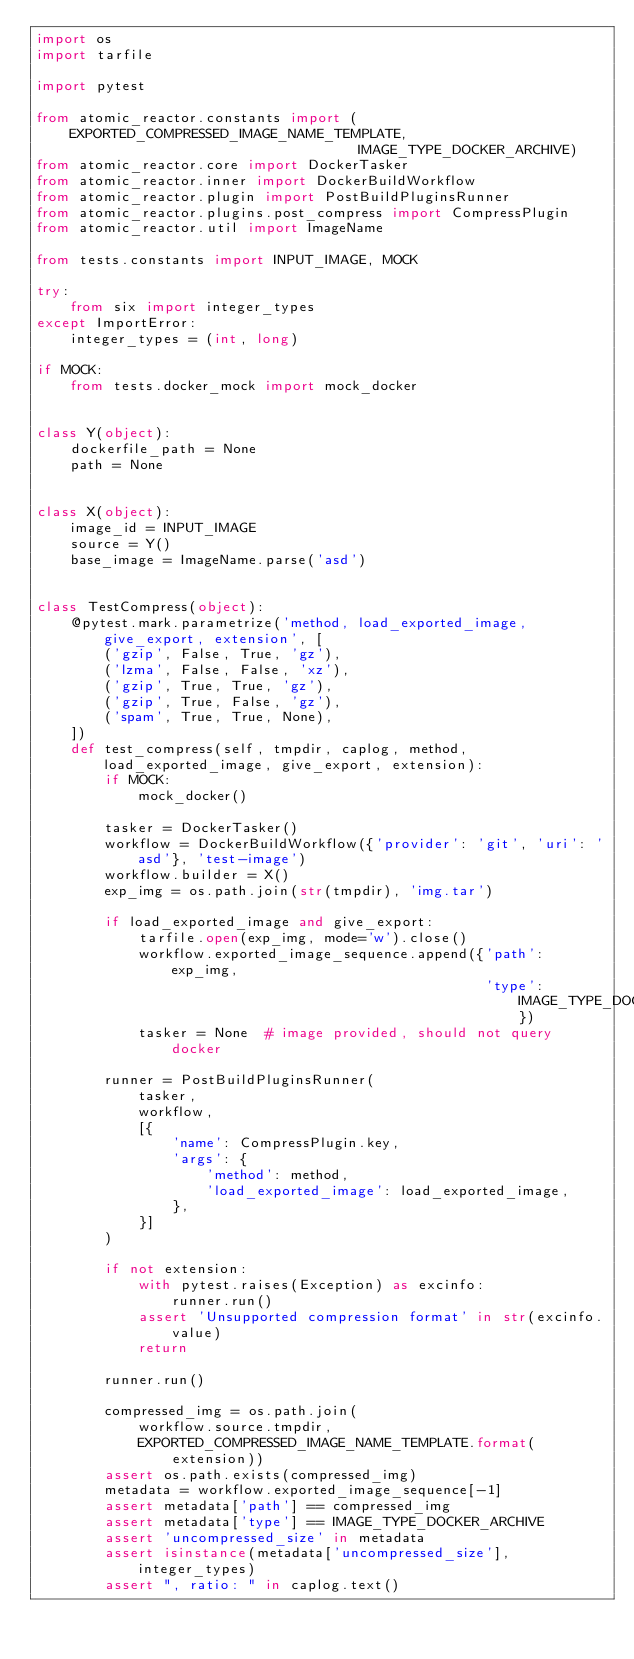Convert code to text. <code><loc_0><loc_0><loc_500><loc_500><_Python_>import os
import tarfile

import pytest

from atomic_reactor.constants import (EXPORTED_COMPRESSED_IMAGE_NAME_TEMPLATE,
                                      IMAGE_TYPE_DOCKER_ARCHIVE)
from atomic_reactor.core import DockerTasker
from atomic_reactor.inner import DockerBuildWorkflow
from atomic_reactor.plugin import PostBuildPluginsRunner
from atomic_reactor.plugins.post_compress import CompressPlugin
from atomic_reactor.util import ImageName

from tests.constants import INPUT_IMAGE, MOCK

try:
    from six import integer_types
except ImportError:
    integer_types = (int, long)

if MOCK:
    from tests.docker_mock import mock_docker


class Y(object):
    dockerfile_path = None
    path = None


class X(object):
    image_id = INPUT_IMAGE
    source = Y()
    base_image = ImageName.parse('asd')


class TestCompress(object):
    @pytest.mark.parametrize('method, load_exported_image, give_export, extension', [
        ('gzip', False, True, 'gz'),
        ('lzma', False, False, 'xz'),
        ('gzip', True, True, 'gz'),
        ('gzip', True, False, 'gz'),
        ('spam', True, True, None),
    ])
    def test_compress(self, tmpdir, caplog, method, load_exported_image, give_export, extension):
        if MOCK:
            mock_docker()

        tasker = DockerTasker()
        workflow = DockerBuildWorkflow({'provider': 'git', 'uri': 'asd'}, 'test-image')
        workflow.builder = X()
        exp_img = os.path.join(str(tmpdir), 'img.tar')

        if load_exported_image and give_export:
            tarfile.open(exp_img, mode='w').close()
            workflow.exported_image_sequence.append({'path': exp_img,
                                                     'type': IMAGE_TYPE_DOCKER_ARCHIVE})
            tasker = None  # image provided, should not query docker

        runner = PostBuildPluginsRunner(
            tasker,
            workflow,
            [{
                'name': CompressPlugin.key,
                'args': {
                    'method': method,
                    'load_exported_image': load_exported_image,
                },
            }]
        )

        if not extension:
            with pytest.raises(Exception) as excinfo:
                runner.run()
            assert 'Unsupported compression format' in str(excinfo.value)
            return

        runner.run()

        compressed_img = os.path.join(
            workflow.source.tmpdir,
            EXPORTED_COMPRESSED_IMAGE_NAME_TEMPLATE.format(extension))
        assert os.path.exists(compressed_img)
        metadata = workflow.exported_image_sequence[-1]
        assert metadata['path'] == compressed_img
        assert metadata['type'] == IMAGE_TYPE_DOCKER_ARCHIVE
        assert 'uncompressed_size' in metadata
        assert isinstance(metadata['uncompressed_size'], integer_types)
        assert ", ratio: " in caplog.text()
</code> 